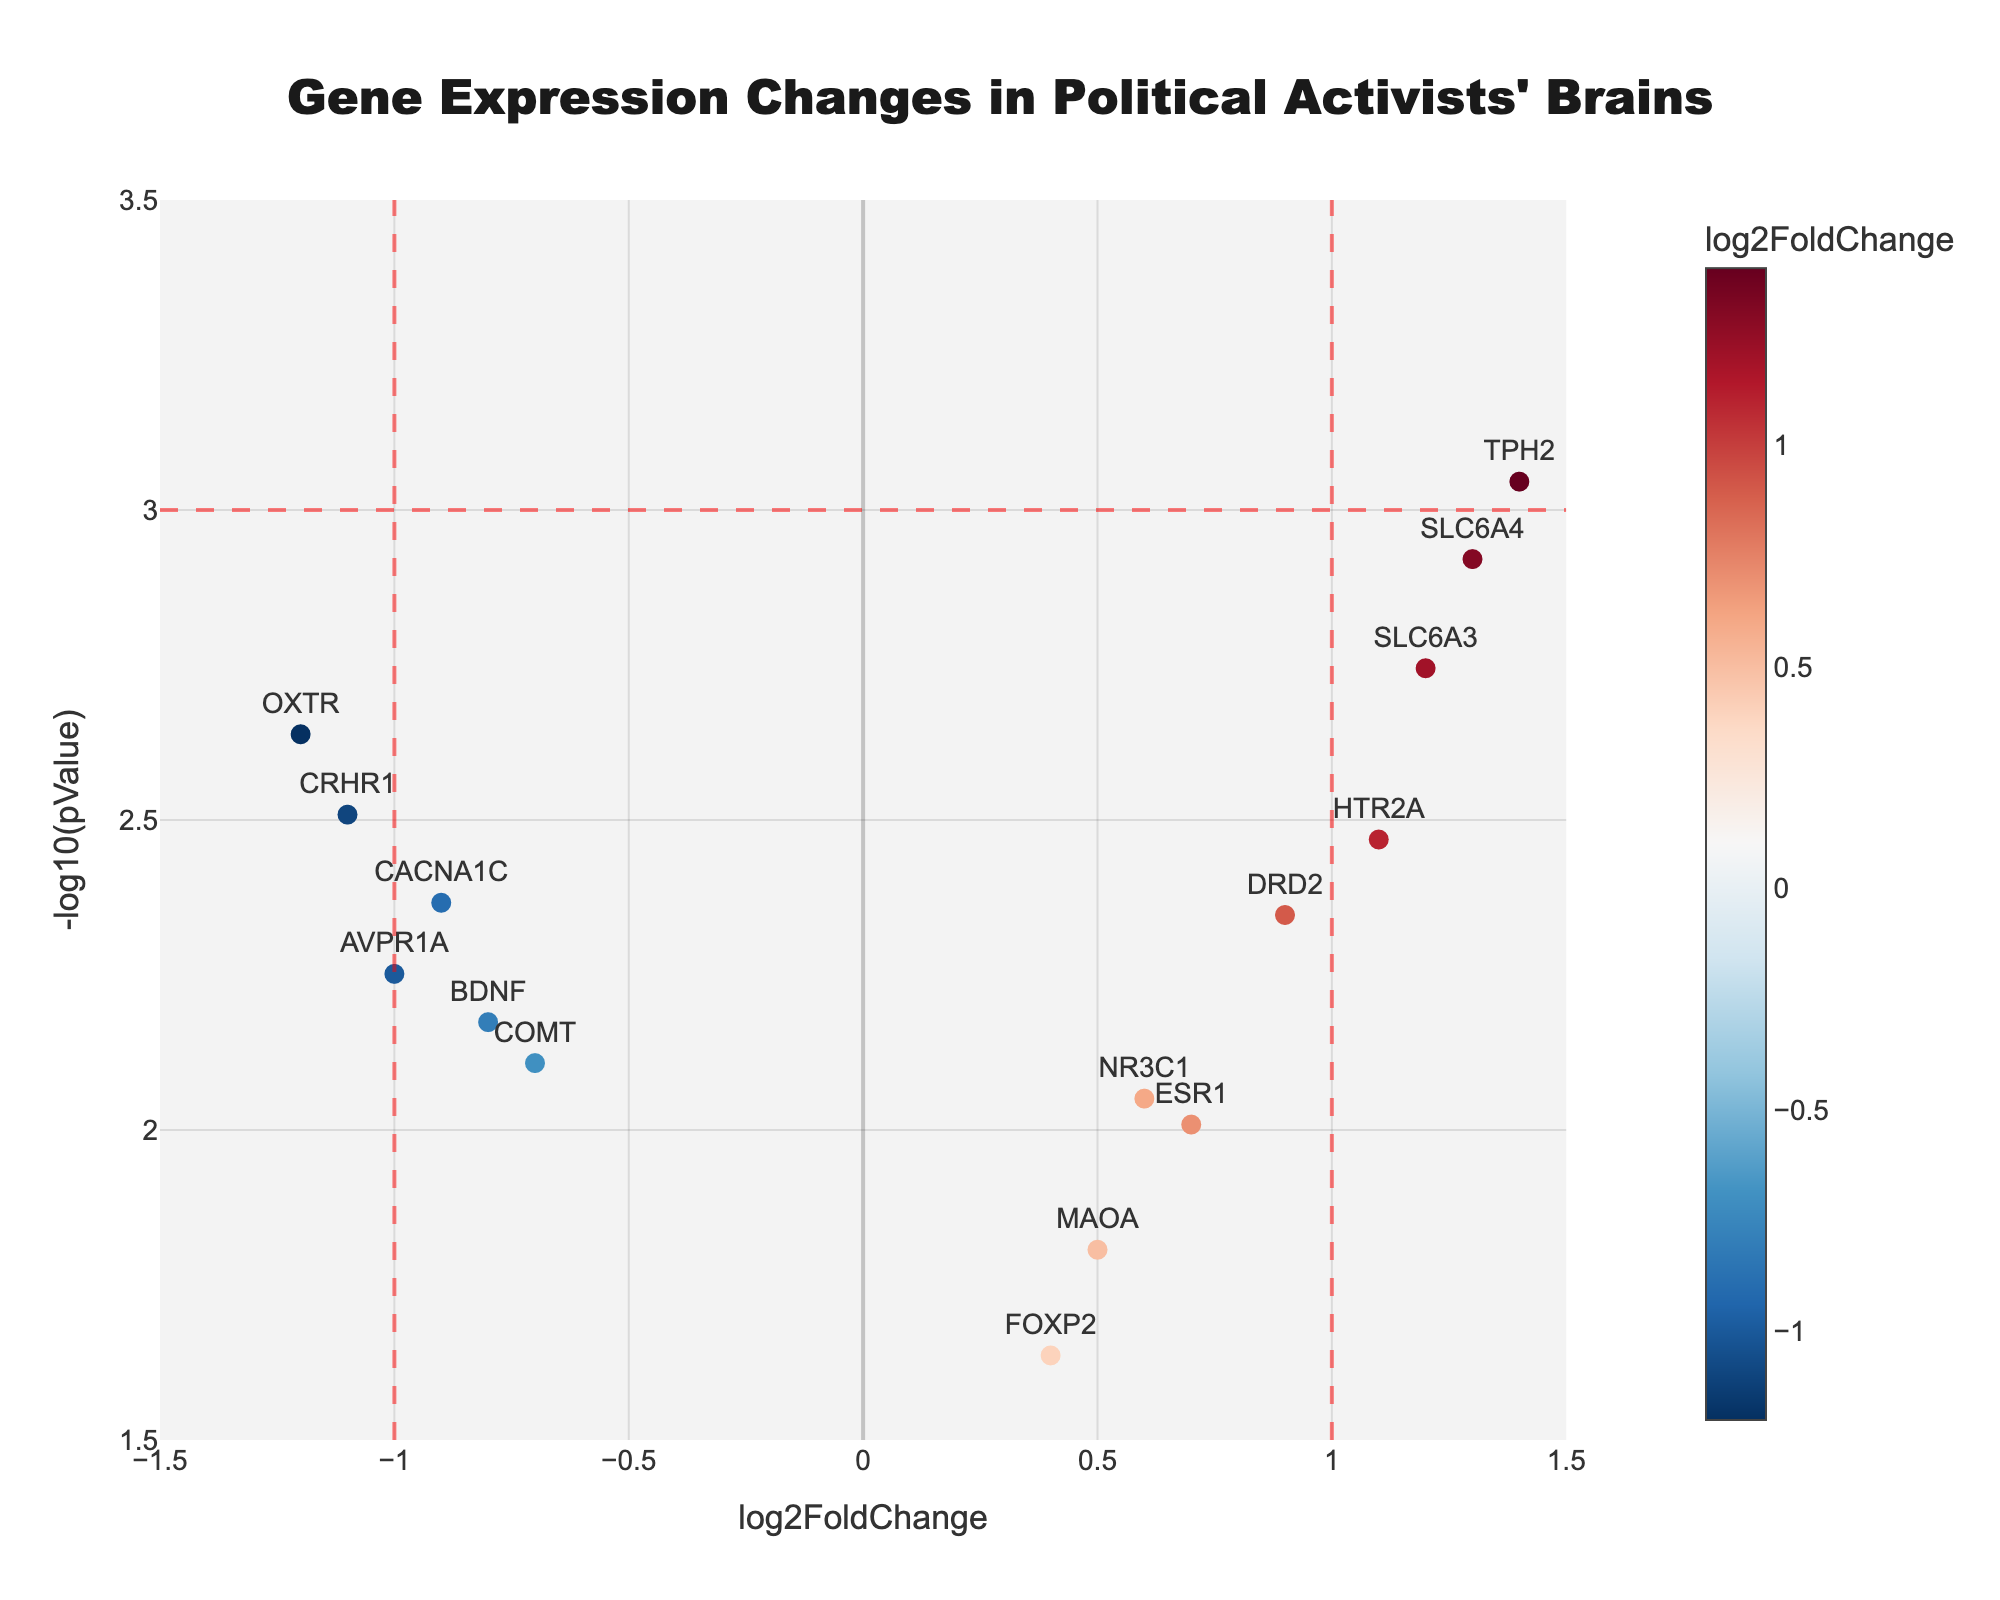What is the title of the plot? The title of the plot is displayed at the top of the figure, which reads "Gene Expression Changes in Political Activists' Brains."
Answer: Gene Expression Changes in Political Activists' Brains What do the x-axis and y-axis represent? The x-axis represents the log2FoldChange of gene expression, indicating how much the expression levels of genes change, while the y-axis represents -log10(pValue), indicating the statistical significance of these changes.
Answer: log2FoldChange and -log10(pValue) How many genes show a log2FoldChange greater than 1 or less than -1? By examining the plot, we can count the genes that lie beyond the vertical lines at log2FoldChange = 1 and log2FoldChange = -1. Five genes (SLC6A4, TPH2, HTR2A, SLC6A3, DRD2) have log2FoldChange > 1, and two genes (OXTR, CRHR1) have log2FoldChange < -1.
Answer: 7 Which gene has the highest -log10(pValue)? The gene with the highest -log10(pValue) will be positioned the highest on the y-axis. TPH2 has the highest -log10(pValue).
Answer: TPH2 What gene is represented by the point with log2FoldChange approximately equal to 0.6 and -log10(pValue) approximately equal to 2.05? By finding the point near log2FoldChange = 0.6 and -log10(pValue) ≈ 2.05, we see it corresponds to the gene NR3C1.
Answer: NR3C1 Which gene has the largest positive change in log2FoldChange, and what is its p-value? The gene with the largest positive change will be the point furthest to the right on the plot. The gene is TPH2 with a log2FoldChange of 1.4, and its p-value can be derived from the corresponding y-axis value, which is approximately 0.0009.
Answer: TPH2, 0.0009 How many genes have a -log10(pValue) greater than 3? To determine this, we count the points above the horizontal line at -log10(pValue) = 3. Three genes (SLC6A4, TPH2, SLC6A3) are above this line.
Answer: 3 Which gene has a -log10(pValue) close to 2.5 and a log2FoldChange in between 0 and -1? Looking for the point near -log10(pValue) = 2.5 and log2FoldChange between 0 and -1, we find the gene COMT matches this description.
Answer: COMT Compare the log2FoldChange of OXTR and AVPR1A. Which one shows a greater negative change? Both genes show negative changes indicated by their log2FoldChange values. OXTR has a log2FoldChange of -1.2, while AVPR1A has -1.0. Since -1.2 is more negative than -1.0, OXTR shows a greater negative change.
Answer: OXTR Which gene has the smallest -log10(pValue) and what is its log2FoldChange? The gene with the smallest -log10(pValue) will be closest to the bottom of the y-axis. FOXP2 has the smallest -log10(pValue) and its log2FoldChange is 0.4.
Answer: FOXP2, 0.4 